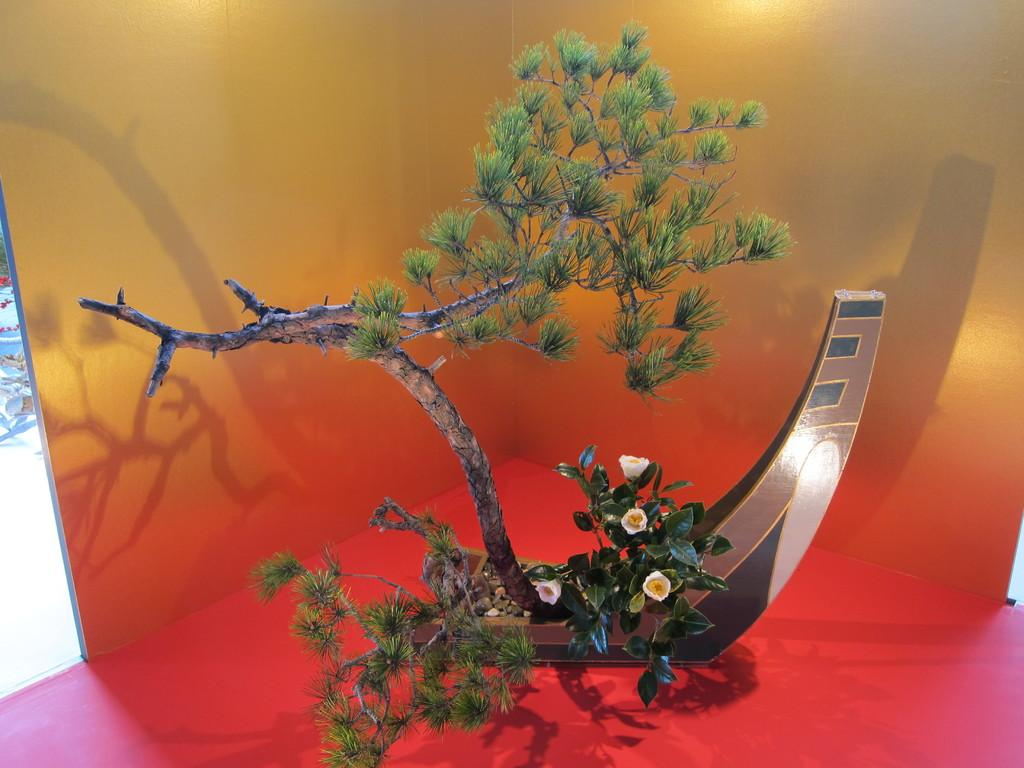What type of vegetation is present in the image? There is a tree and plants in the image. Can you describe the plant with flowers in the image? Yes, there is a plant with flowers in the image. What colors can be seen in the background of the image? The background of the image includes yellow and red colors. How many baseballs are floating in the water near the tree in the image? There are no baseballs present in the image; it features a tree, plants, and a plant with flowers. Can you describe the process of the jellyfish swimming in the image? There are no jellyfish present in the image; it features a tree, plants, and a plant with flowers. 